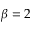<formula> <loc_0><loc_0><loc_500><loc_500>\beta = 2</formula> 